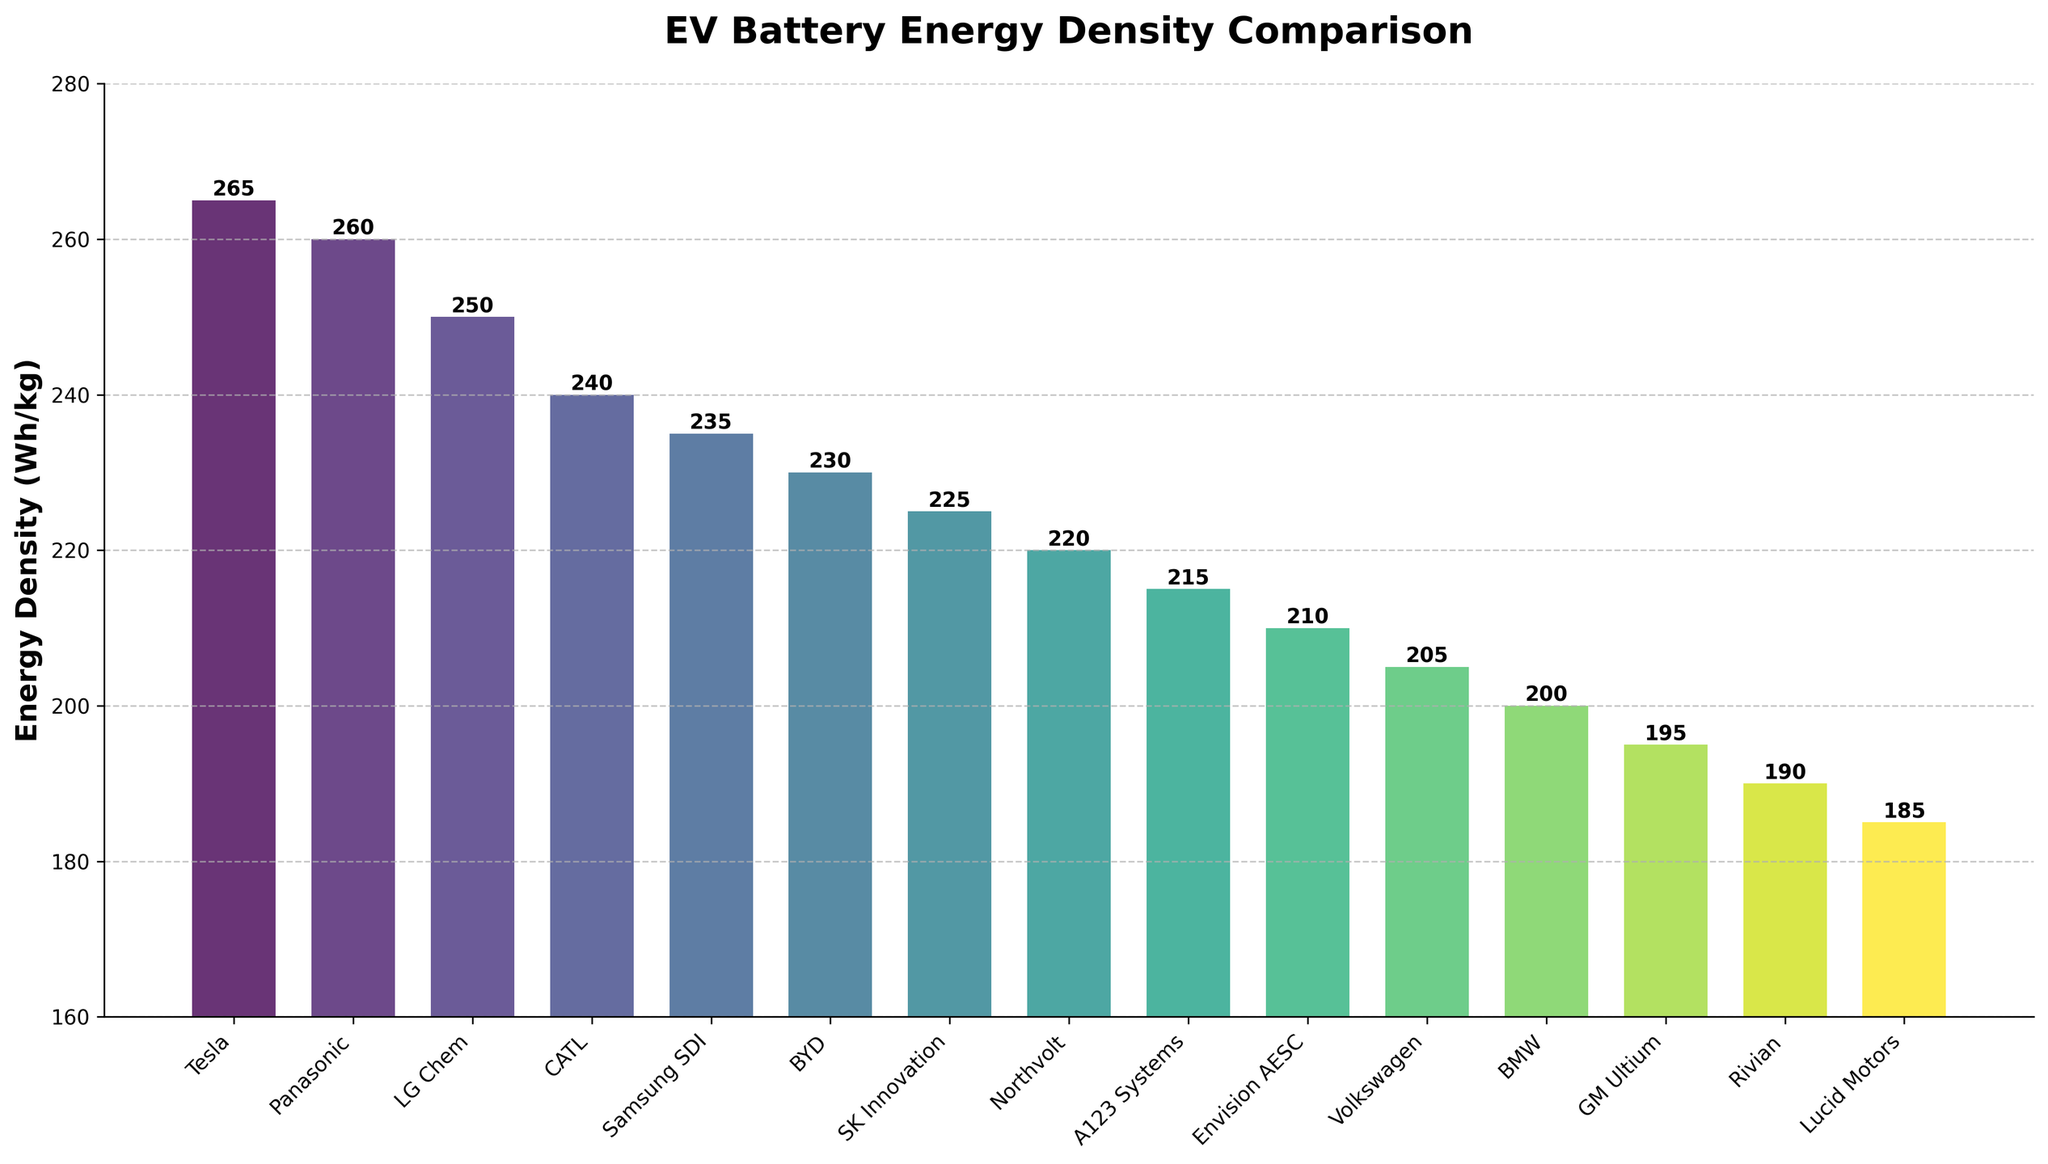What is the energy density of the manufacturer with the highest value? The bar representing Tesla has the highest value on the y-axis. The height label shows the energy density is 265 Wh/kg.
Answer: 265 Wh/kg Which two manufacturers have the smallest difference in energy density? Panasonic and Tesla show the closest values with energy densities of 260 Wh/kg and 265 Wh/kg, respectively, giving a difference of 5 Wh/kg.
Answer: Panasonic and Tesla How many manufacturers have energy densities greater than 250 Wh/kg? Tesla, Panasonic, and LG Chem have energy densities of 265 Wh/kg, 260 Wh/kg, and 250 Wh/kg respectively. There are 3 such manufacturers.
Answer: 3 What is the difference in energy density between CATL and GM Ultium? The energy density of CATL is 240 Wh/kg and GM Ultium is 195 Wh/kg. The difference is 240 - 195 = 45 Wh/kg.
Answer: 45 Wh/kg What is the average energy density of the top 5 manufacturers? The energy densities are Tesla (265), Panasonic (260), LG Chem (250), CATL (240), and Samsung SDI (235). The average is (265 + 260 + 250 + 240 + 235) / 5 = 250 Wh/kg.
Answer: 250 Wh/kg Which manufacturer lies in the middle position when manufacturers are sorted by energy density in ascending order? When sorted, Volkswagen, BMW, GM Ultium, Rivian, and Lucid Motors form the lowest group, with Volkswagen (205 Wh/kg) being the central manufacturer.
Answer: Volkswagen Compare the energy densities of the lowest and highest manufacturers. The bar for Lucid Motors is the lowest, with an energy density of 185 Wh/kg, and Tesla has the highest at 265 Wh/kg. The difference is 265 - 185 = 80 Wh/kg.
Answer: 80 Wh/kg Which color bar appears for the manufacturer Samsung SDI and where is it positioned in the chart? Samsung SDI is in the middle of the chart, with an energy density of 235 Wh/kg, and its bar is colored in the middle of the color gradient from the viridis colormap.
Answer: Middle color (greenish), middle position What is the median energy density of all listed manufacturers? To find the median, list all energy densities in order: [185, 190, 195, 200, 205, 210, 215, 220, 225, 230, 235, 240, 250, 260, 265]. The median value, being the 8th number in a list of 15, is 220 Wh/kg.
Answer: 220 Wh/kg 